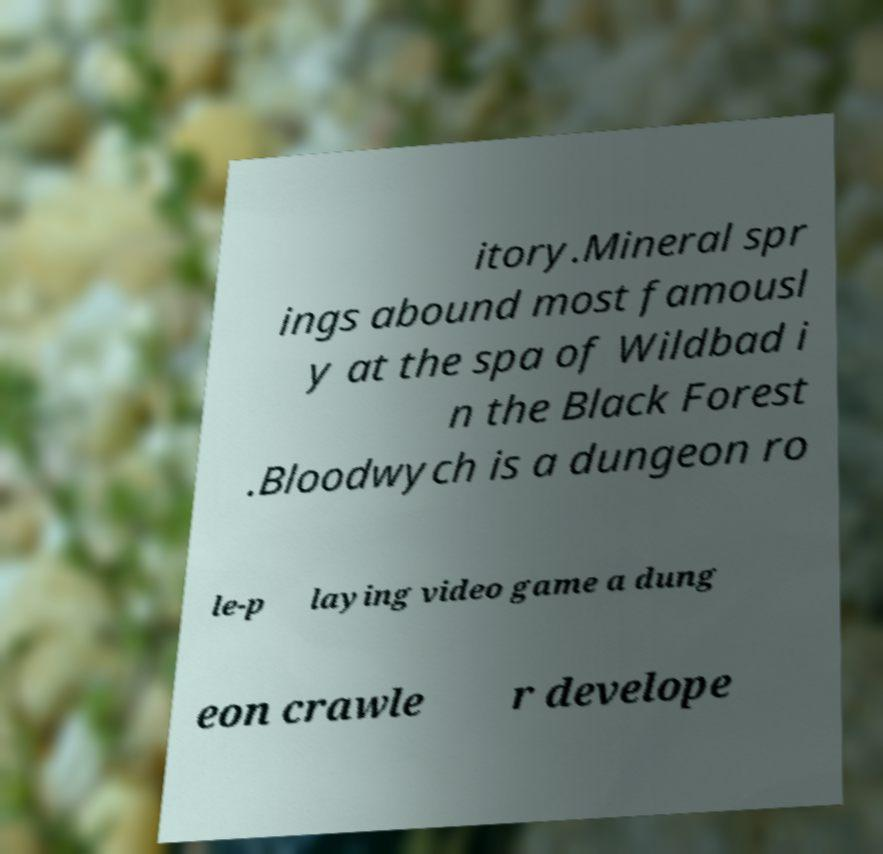Can you read and provide the text displayed in the image?This photo seems to have some interesting text. Can you extract and type it out for me? itory.Mineral spr ings abound most famousl y at the spa of Wildbad i n the Black Forest .Bloodwych is a dungeon ro le-p laying video game a dung eon crawle r develope 